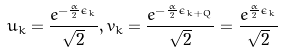<formula> <loc_0><loc_0><loc_500><loc_500>u _ { k } = \frac { e ^ { - \frac { \alpha } { 2 } \epsilon _ { k } } } { \sqrt { 2 } } , v _ { k } = \frac { e ^ { - \frac { \alpha } { 2 } \epsilon _ { k + Q } } } { \sqrt { 2 } } = \frac { e ^ { \frac { \alpha } { 2 } \epsilon _ { k } } } { \sqrt { 2 } }</formula> 